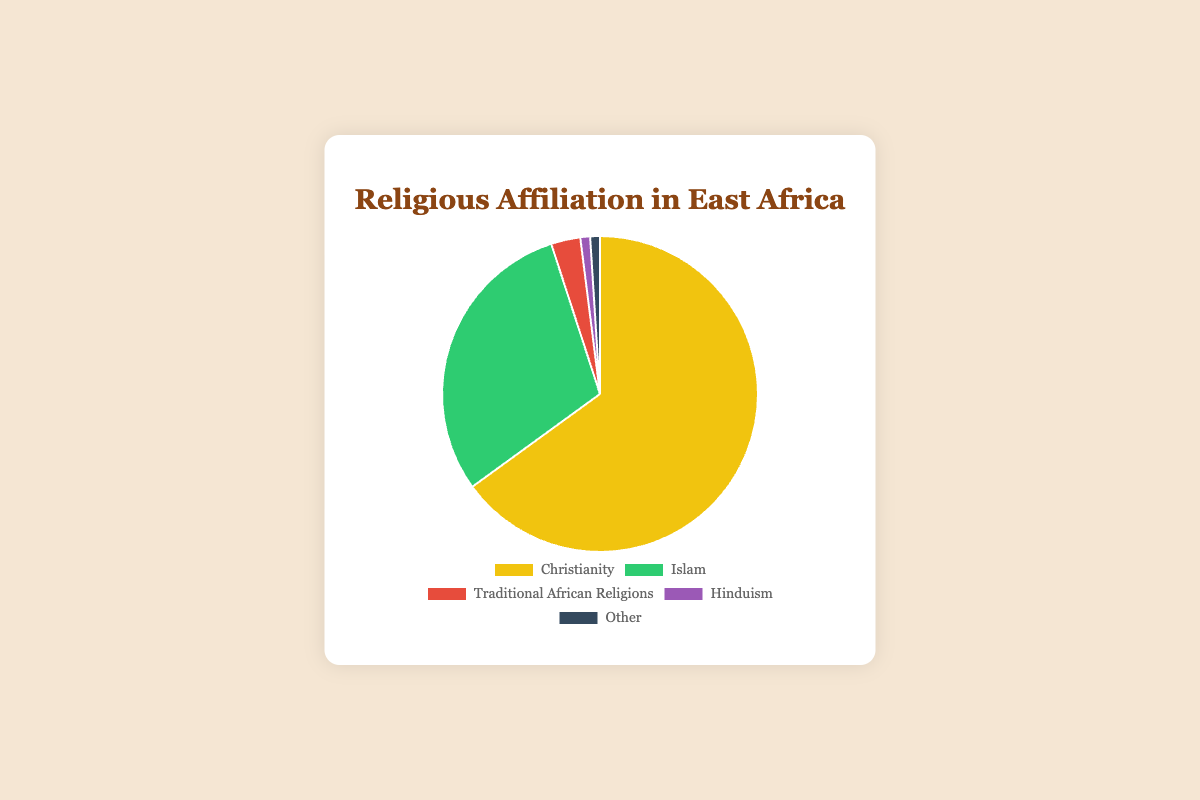What is the most prevalent religion in East Africa? By looking at the pie chart, we can see that Christianity has the largest portion. The percentage for Christianity is 65%.
Answer: Christianity Which religions have the same percentage of followers in East Africa? The pie chart indicates that both Hinduism and 'Other' share the same percentage of 1%.
Answer: Hinduism and Other How much more prevalent is Christianity compared to Islam in East Africa? To find out how much more prevalent Christianity is compared to Islam, we subtract the percentage of Islam from Christianity. Christianity is 65%, while Islam is 30%, so 65% - 30% = 35%.
Answer: 35% What is the combined percentage of followers of Traditional African Religions and Hinduism in East Africa? To find the combined percentage, we add the percentages of Traditional African Religions (3%) and Hinduism (1%). 3% + 1% = 4%.
Answer: 4% If Traditional African Religions and 'Other' were combined, would they still be smaller than Islam? To find out, we add the percentages of Traditional African Religions (3%) and 'Other' (1%). 3% + 1% = 4%. Since Islam has 30%, 4% is indeed smaller than 30%.
Answer: Yes How many times greater is the percentage of Christians compared to followers of Traditional African Religions in East Africa? To find how many times greater the percentage of Christians is compared to followers of Traditional African Religions, divide the percentage of Christians (65%) by that of Traditional African Religions (3%). 65 / 3 ≈ 21.67.
Answer: About 21.67 times Which religion is represented by the red section of the pie chart? By examining the color of each section in the pie chart, the red section corresponds to Traditional African Religions.
Answer: Traditional African Religions If the percentages of all non-Christian religions were combined, would they exceed half of the total population in East Africa? Combining the percentages of all non-Christian religions: Islam (30%) + Traditional African Religions (3%) + Hinduism (1%) + Other (1%) = 35%. Since 35% is less than 50%, they do not exceed half of the total population.
Answer: No 